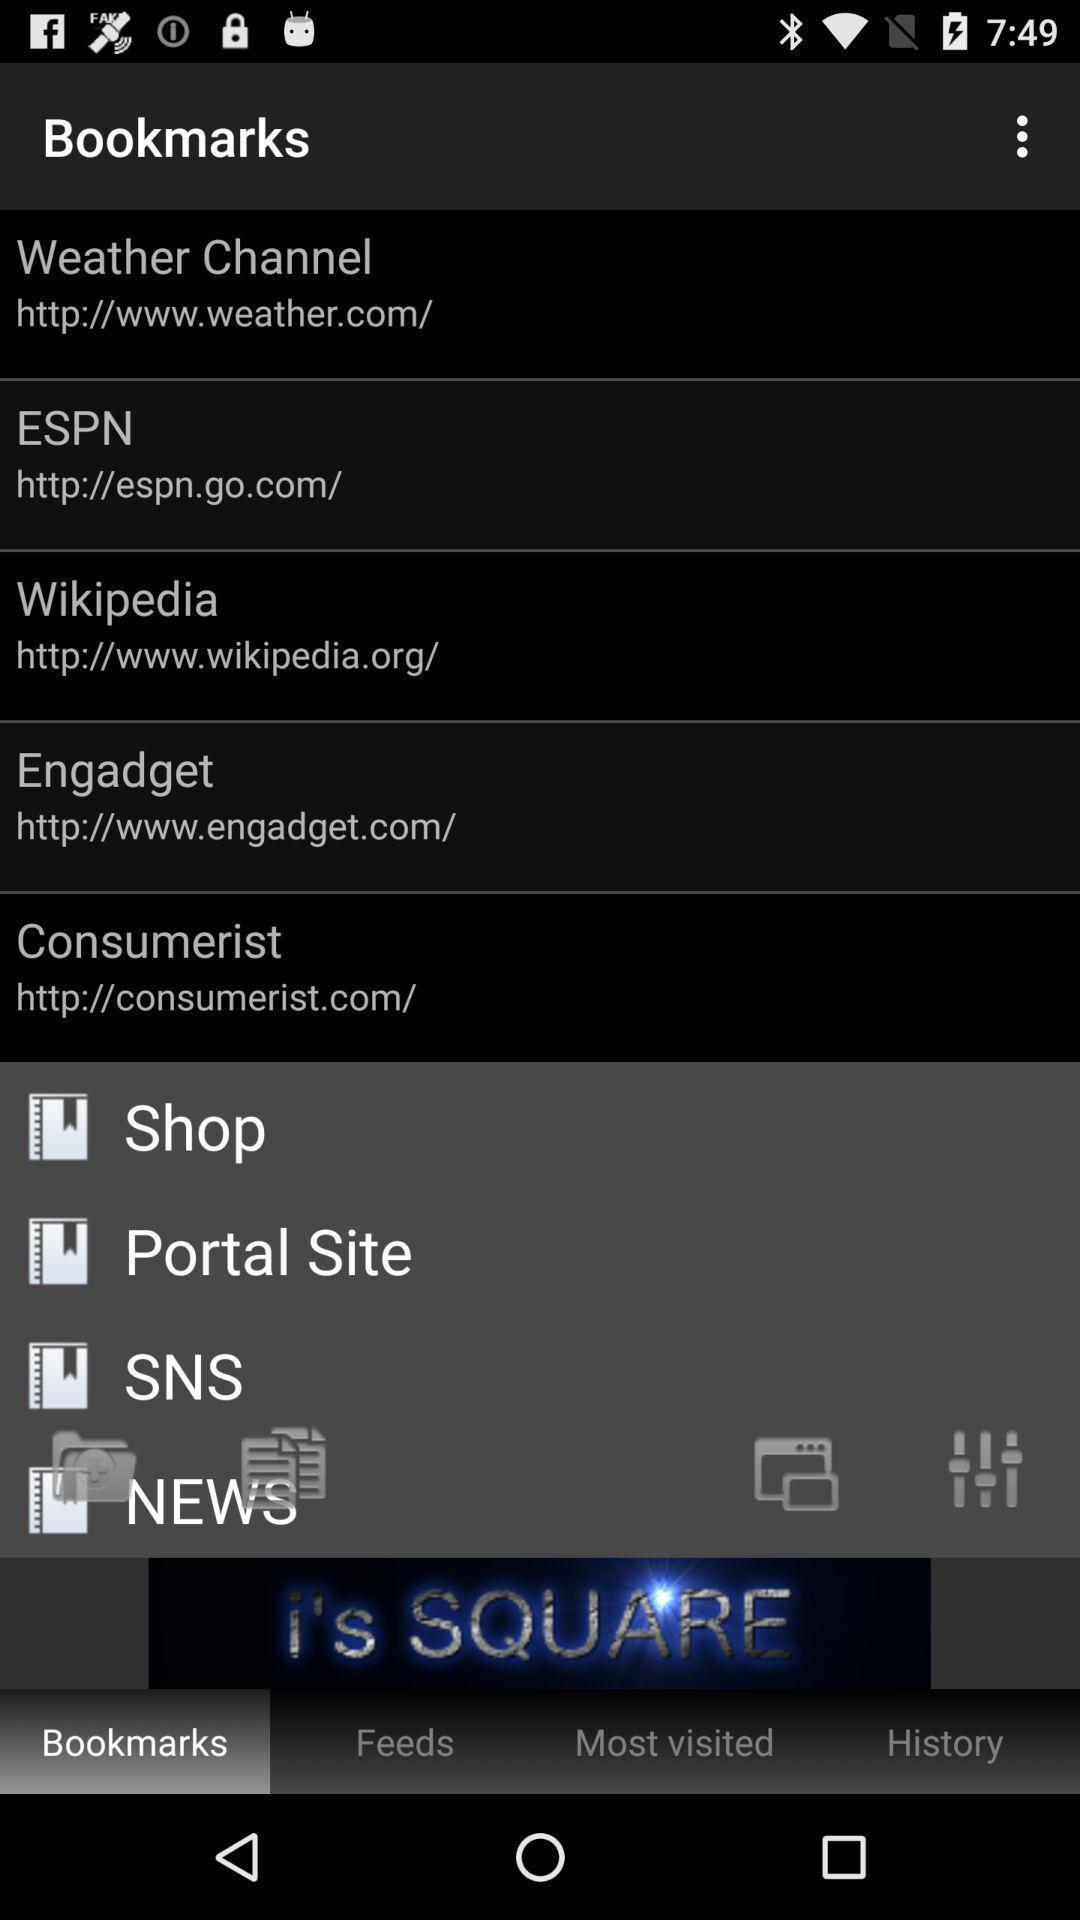What is the URL of the "ESPN" bookmark? The URL is http://espn.go.com/. 